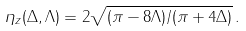Convert formula to latex. <formula><loc_0><loc_0><loc_500><loc_500>\eta _ { z } ( \Delta , \Lambda ) = 2 \sqrt { ( \pi - 8 \Lambda ) / ( \pi + 4 \Delta ) } \, .</formula> 